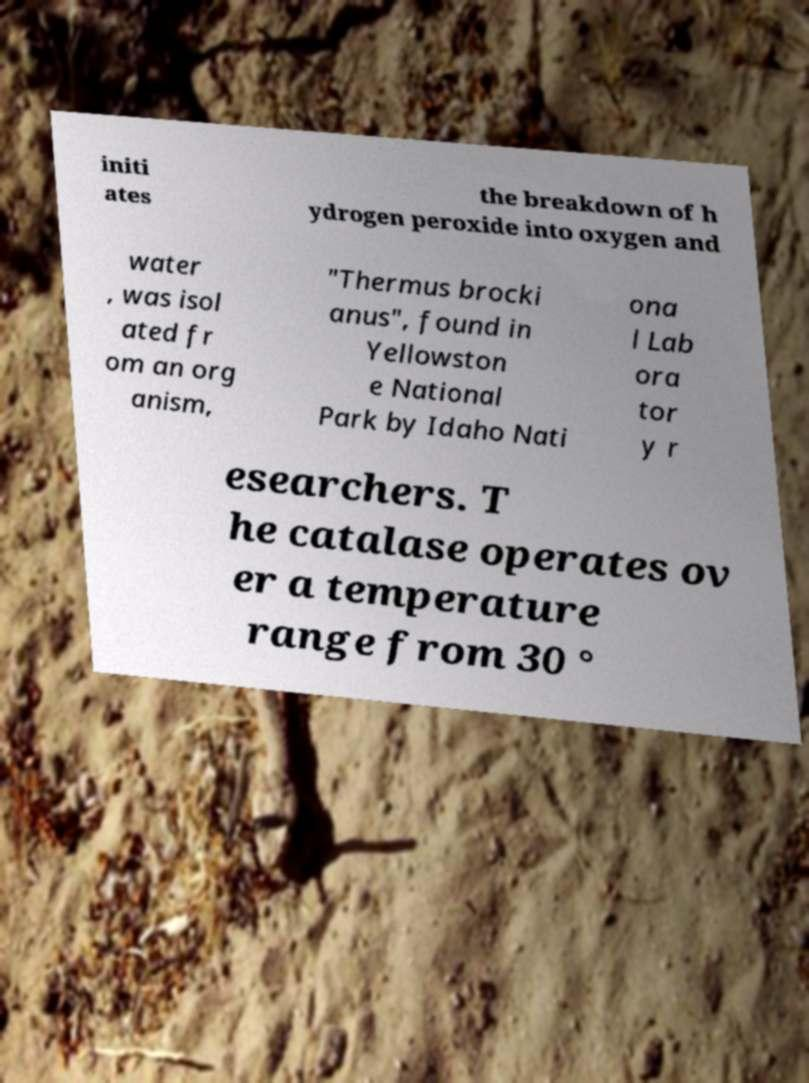What messages or text are displayed in this image? I need them in a readable, typed format. initi ates the breakdown of h ydrogen peroxide into oxygen and water , was isol ated fr om an org anism, "Thermus brocki anus", found in Yellowston e National Park by Idaho Nati ona l Lab ora tor y r esearchers. T he catalase operates ov er a temperature range from 30 ° 